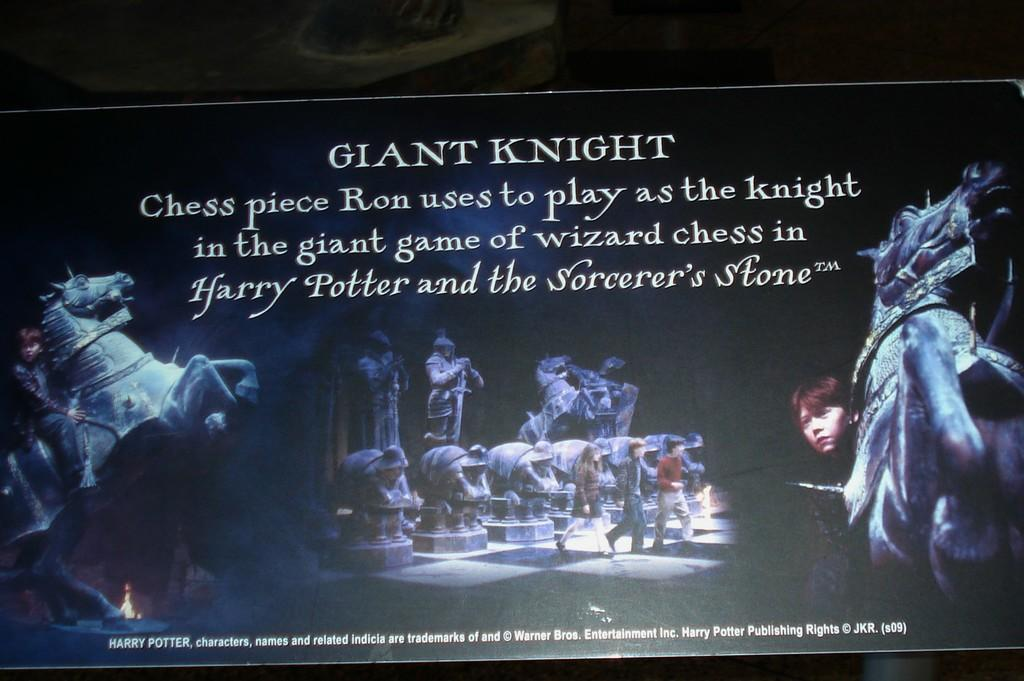What is the main subject in the center of the image? There is a flex banner in the center of the image. What can be seen on the flex banner? There are people, text, and other objects on the flex banner. What is the color of the background in the image? The background of the image is dark. Can you tell me how many tins are being sorted on the flex banner? There are no tins present in the image, and no sorting activity is depicted. What type of game are the people playing on the flex banner? There is no game being played on the flex banner; the people are simply standing or interacting with the other objects present. 